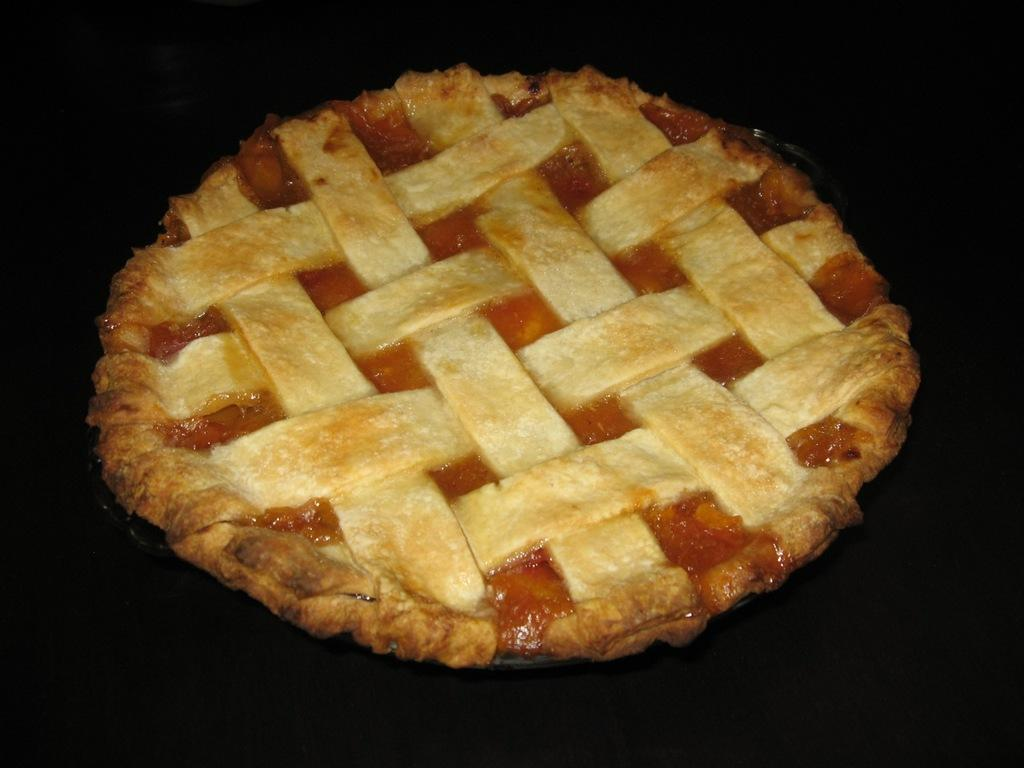What is the main subject of the image? There is a pie in the image. What can be observed about the background of the image? The background of the image is dark. What type of humor is being displayed by the cars in the image? There are no cars present in the image, so it is not possible to determine what type of humor might be displayed by them. 